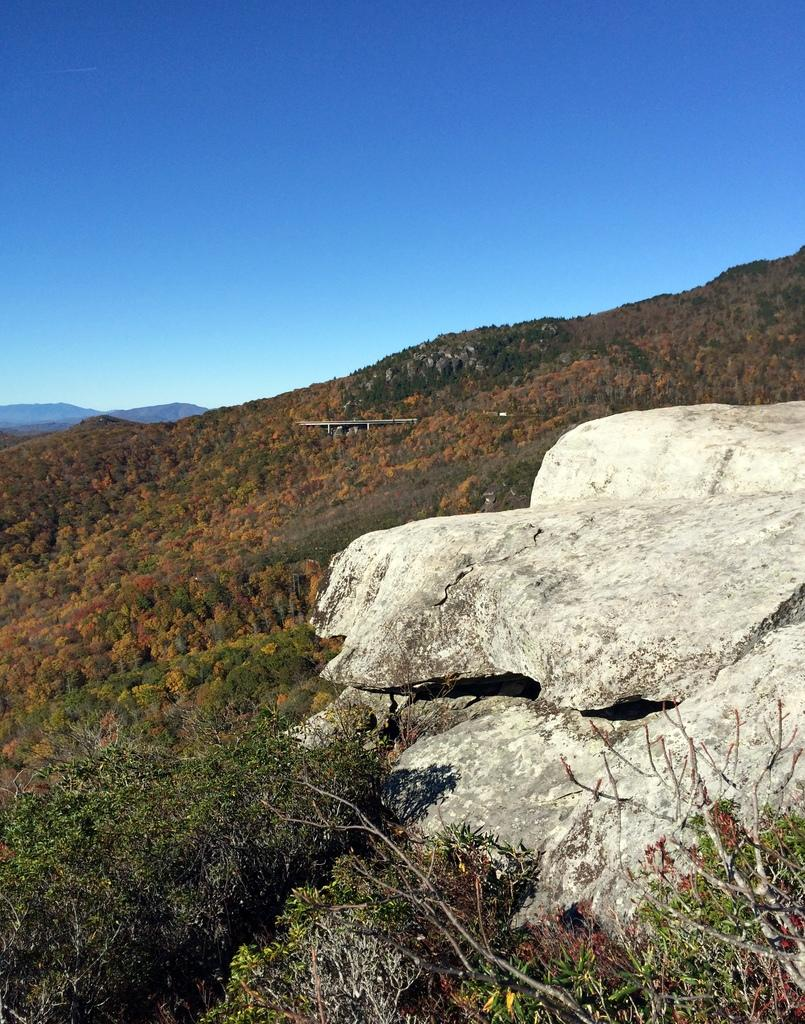What type of natural elements can be seen in the image? There are rocks and trees in the image. What is visible in the background of the image? The sky is visible in the background of the image. What is the color of the sky in the image? The color of the sky is blue. Can you tell me how many bones are present in the image? There are no bones present in the image; it features rocks and trees. Is there a cactus visible in the image? There is no cactus present in the image; it features rocks and trees. 